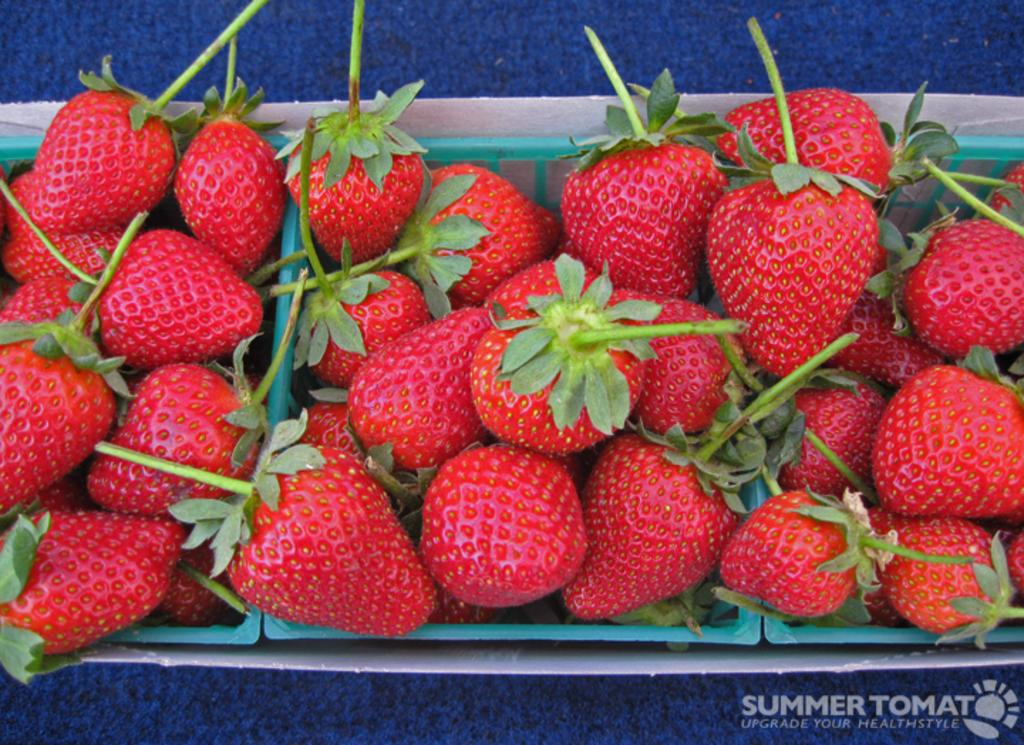What type of fruit is in the box in the image? There are strawberries in a box in the image. What color is the surface on which the box is placed? The box is placed on a blue color surface. Where can text be found in the image? There is some text on the right side of the image. What type of lipstick is shown on the border of the image? There is no lipstick or border present in the image; it only features a box of strawberries and some text. 